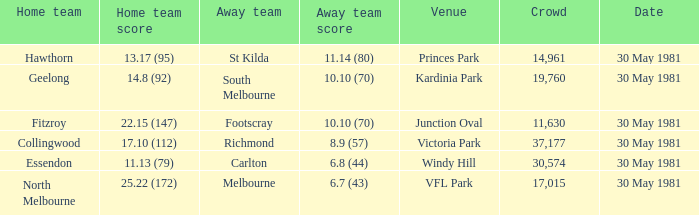What is the home ground of essendon accommodating more than 19,760 spectators? Windy Hill. 